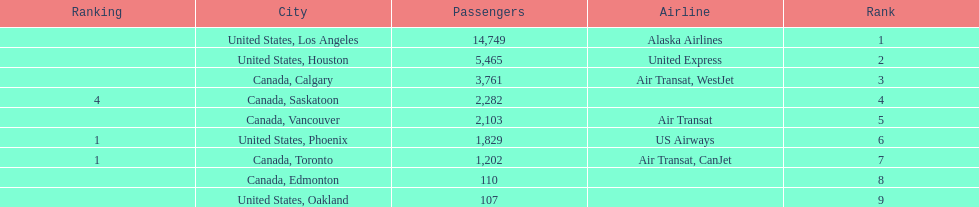How many cities from canada are on this list? 5. 